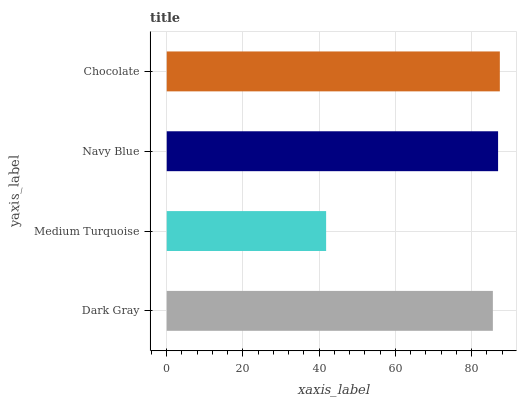Is Medium Turquoise the minimum?
Answer yes or no. Yes. Is Chocolate the maximum?
Answer yes or no. Yes. Is Navy Blue the minimum?
Answer yes or no. No. Is Navy Blue the maximum?
Answer yes or no. No. Is Navy Blue greater than Medium Turquoise?
Answer yes or no. Yes. Is Medium Turquoise less than Navy Blue?
Answer yes or no. Yes. Is Medium Turquoise greater than Navy Blue?
Answer yes or no. No. Is Navy Blue less than Medium Turquoise?
Answer yes or no. No. Is Navy Blue the high median?
Answer yes or no. Yes. Is Dark Gray the low median?
Answer yes or no. Yes. Is Medium Turquoise the high median?
Answer yes or no. No. Is Chocolate the low median?
Answer yes or no. No. 